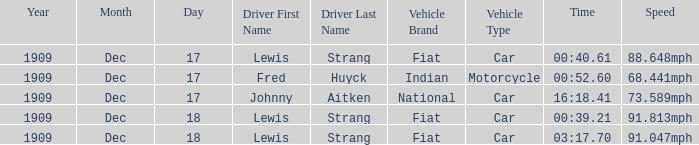Which driver is Indian? Fred Huyck. 